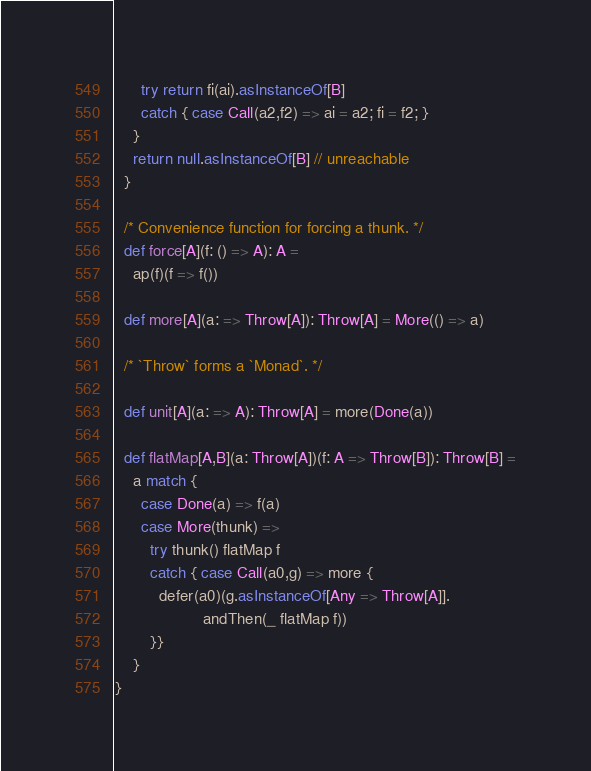<code> <loc_0><loc_0><loc_500><loc_500><_Scala_>      try return fi(ai).asInstanceOf[B]
      catch { case Call(a2,f2) => ai = a2; fi = f2; }
    }
    return null.asInstanceOf[B] // unreachable
  }

  /* Convenience function for forcing a thunk. */
  def force[A](f: () => A): A =
    ap(f)(f => f())

  def more[A](a: => Throw[A]): Throw[A] = More(() => a)

  /* `Throw` forms a `Monad`. */

  def unit[A](a: => A): Throw[A] = more(Done(a))

  def flatMap[A,B](a: Throw[A])(f: A => Throw[B]): Throw[B] =
    a match {
      case Done(a) => f(a)
      case More(thunk) =>
        try thunk() flatMap f
        catch { case Call(a0,g) => more {
          defer(a0)(g.asInstanceOf[Any => Throw[A]].
                    andThen(_ flatMap f))
        }}
    }
}
</code> 